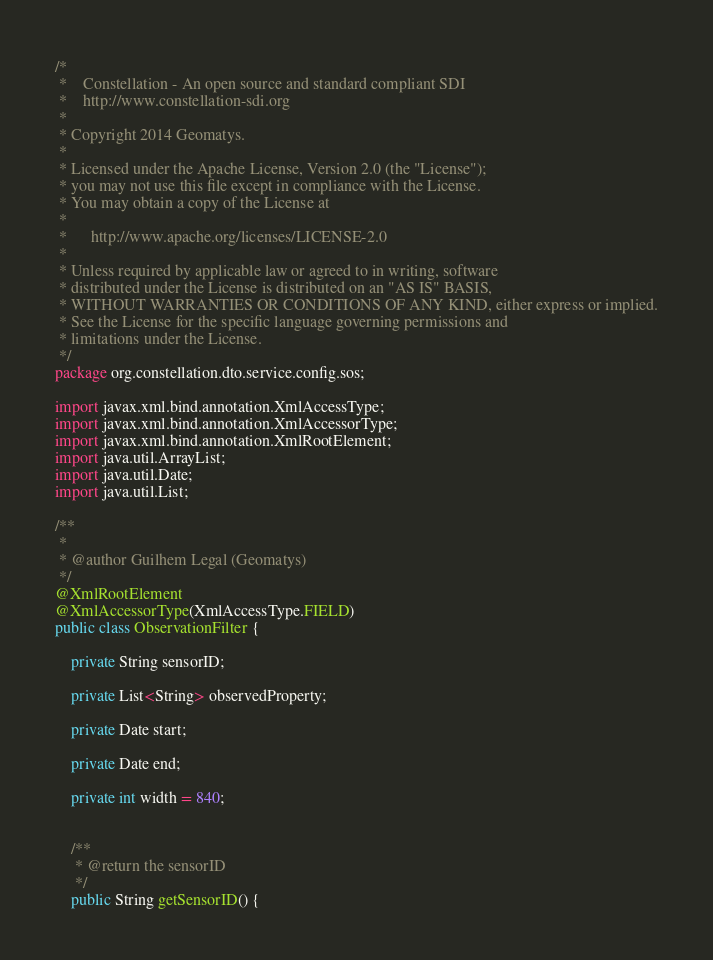Convert code to text. <code><loc_0><loc_0><loc_500><loc_500><_Java_>/*
 *    Constellation - An open source and standard compliant SDI
 *    http://www.constellation-sdi.org
 *
 * Copyright 2014 Geomatys.
 *
 * Licensed under the Apache License, Version 2.0 (the "License");
 * you may not use this file except in compliance with the License.
 * You may obtain a copy of the License at
 *
 *      http://www.apache.org/licenses/LICENSE-2.0
 *
 * Unless required by applicable law or agreed to in writing, software
 * distributed under the License is distributed on an "AS IS" BASIS,
 * WITHOUT WARRANTIES OR CONDITIONS OF ANY KIND, either express or implied.
 * See the License for the specific language governing permissions and
 * limitations under the License.
 */
package org.constellation.dto.service.config.sos;

import javax.xml.bind.annotation.XmlAccessType;
import javax.xml.bind.annotation.XmlAccessorType;
import javax.xml.bind.annotation.XmlRootElement;
import java.util.ArrayList;
import java.util.Date;
import java.util.List;

/**
 *
 * @author Guilhem Legal (Geomatys)
 */
@XmlRootElement
@XmlAccessorType(XmlAccessType.FIELD)
public class ObservationFilter {
    
    private String sensorID;
    
    private List<String> observedProperty;

    private Date start;
    
    private Date end;
    
    private int width = 840;
    
    
    /**
     * @return the sensorID
     */
    public String getSensorID() {</code> 